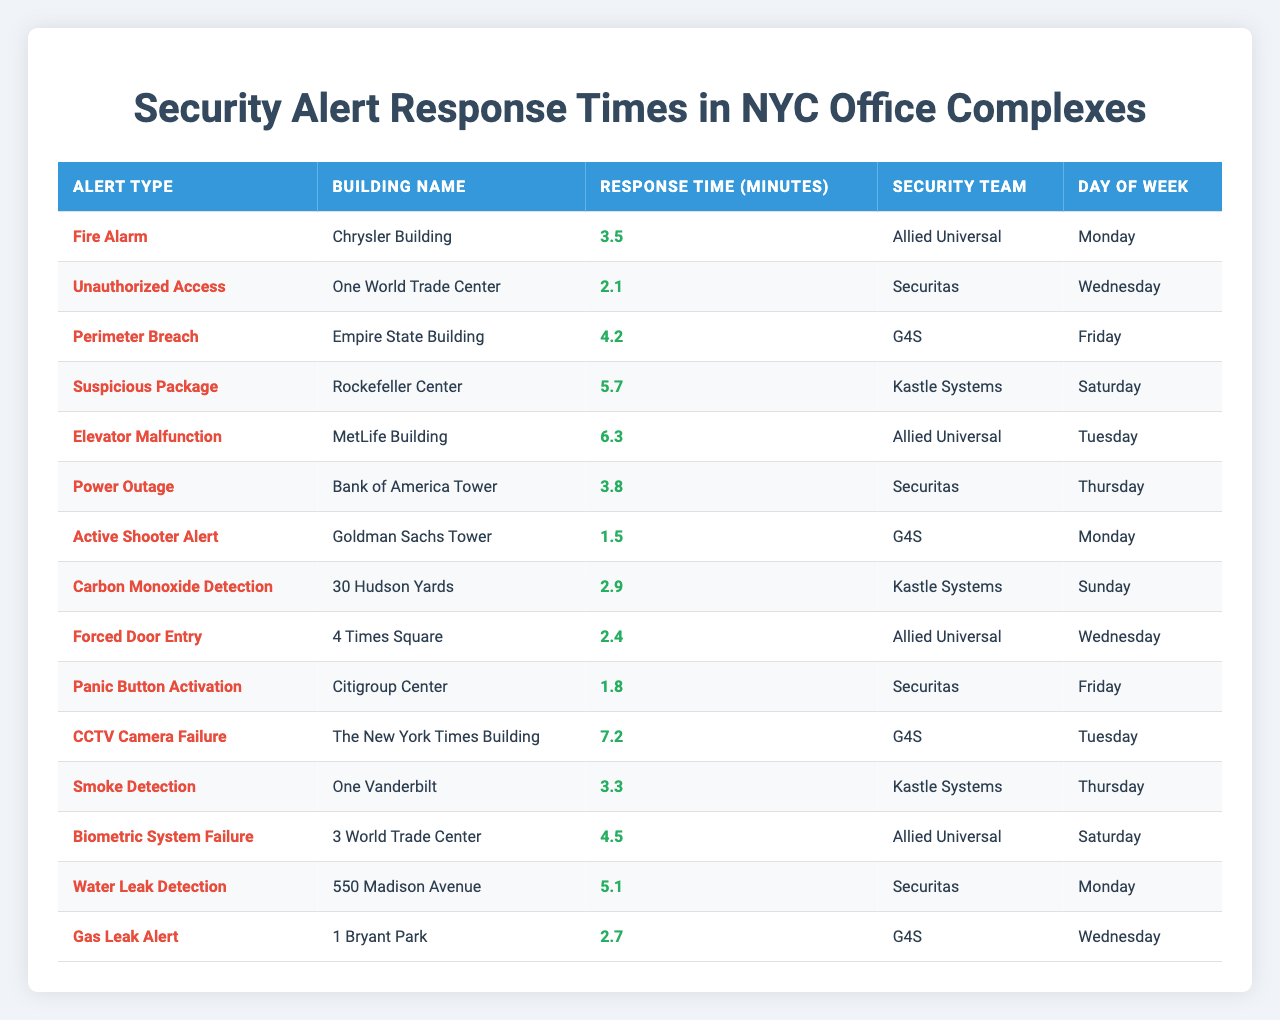What is the response time for the "Fire Alarm" alert at the "Chrysler Building"? The table lists the response time for the "Fire Alarm" alert at the "Chrysler Building" as 3.5 minutes.
Answer: 3.5 minutes Which security team responded the quickest to an alert? Looking through the response times, the quickest alert was the "Active Shooter Alert" handled by "G4S" with a response time of 1.5 minutes.
Answer: G4S What is the average response time for alerts on a Wednesday? There are three alerts listed on Wednesday with response times of 2.1, 2.4, and 2.7 minutes. To find the average, sum these times (2.1 + 2.4 + 2.7 = 7.2) and divide by the number of alerts (7.2/3 = 2.4).
Answer: 2.4 minutes Which alert had the longest response time and what was it? The "CCTV Camera Failure" occurred at "The New York Times Building" with the longest response time of 7.2 minutes.
Answer: CCTV Camera Failure, 7.2 minutes On which day of the week is the "Panic Button Activation" alert reported? The "Panic Button Activation" alert is reported on Friday according to the table.
Answer: Friday How much faster is the "Unauthorized Access" alert response compared to the "Suspicious Package"? The "Unauthorized Access" has a response time of 2.1 minutes and the "Suspicious Package" takes 5.7 minutes. The difference is 5.7 - 2.1 = 3.6 minutes.
Answer: 3.6 minutes Is there any alert that takes longer than 6 minutes? Yes, the "Elevator Malfunction" takes 6.3 minutes and the "CCTV Camera Failure" takes 7.2 minutes, both are longer than 6 minutes.
Answer: Yes What is the total response time for alerts on Monday? There are two alerts on Monday: "Fire Alarm" with 3.5 minutes and "Water Leak Detection" with 5.1 minutes. The total is 3.5 + 5.1 = 8.6 minutes.
Answer: 8.6 minutes Can you name all the buildings that have a response time below 3 minutes? According to the table, there are no alerts with a response time below 3 minutes, as the lowest is 1.5 minutes for the "Active Shooter Alert".
Answer: No What day had the alert with the highest response time? The alert with the highest response time is "CCTV Camera Failure" on Tuesday, with a response time of 7.2 minutes.
Answer: Tuesday, 7.2 minutes 